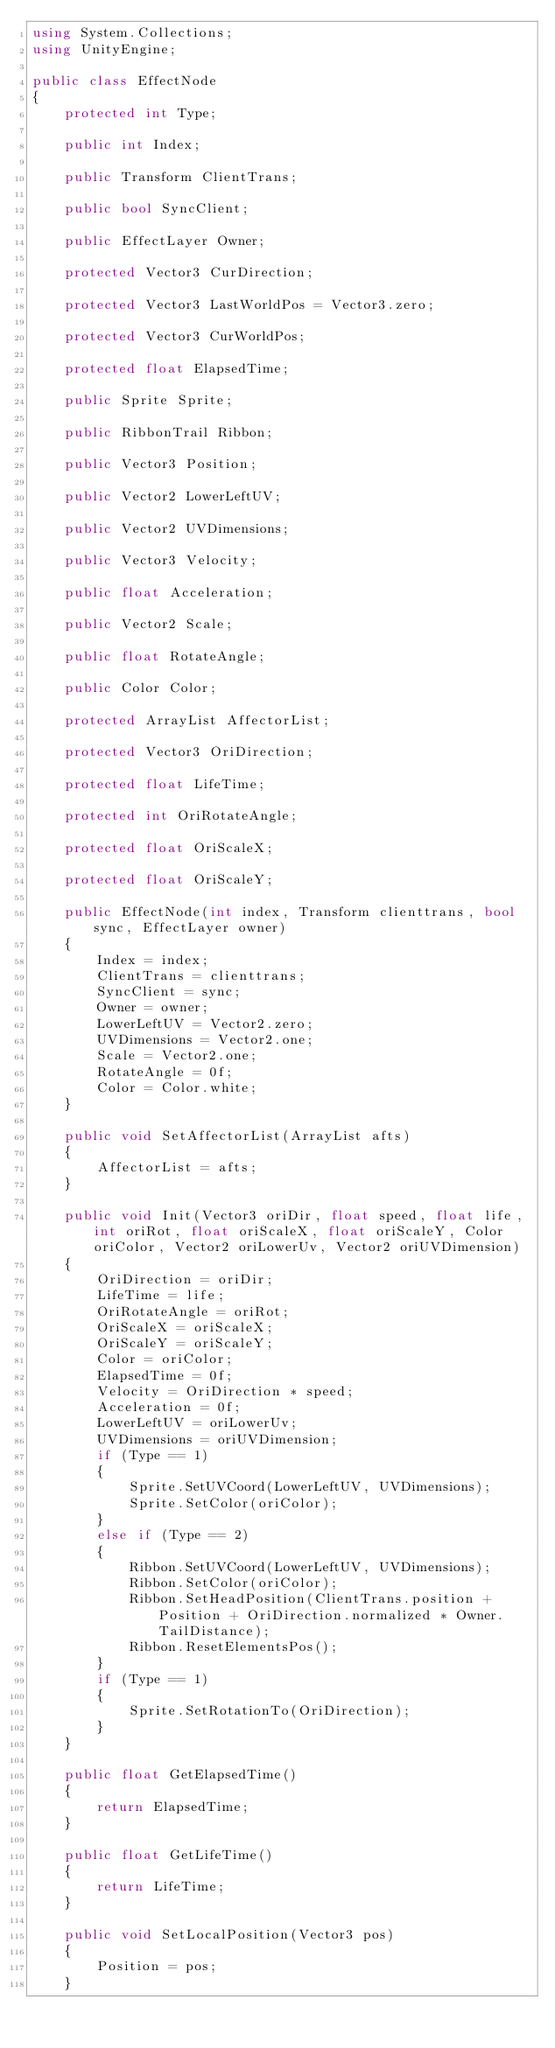<code> <loc_0><loc_0><loc_500><loc_500><_C#_>using System.Collections;
using UnityEngine;

public class EffectNode
{
	protected int Type;

	public int Index;

	public Transform ClientTrans;

	public bool SyncClient;

	public EffectLayer Owner;

	protected Vector3 CurDirection;

	protected Vector3 LastWorldPos = Vector3.zero;

	protected Vector3 CurWorldPos;

	protected float ElapsedTime;

	public Sprite Sprite;

	public RibbonTrail Ribbon;

	public Vector3 Position;

	public Vector2 LowerLeftUV;

	public Vector2 UVDimensions;

	public Vector3 Velocity;

	public float Acceleration;

	public Vector2 Scale;

	public float RotateAngle;

	public Color Color;

	protected ArrayList AffectorList;

	protected Vector3 OriDirection;

	protected float LifeTime;

	protected int OriRotateAngle;

	protected float OriScaleX;

	protected float OriScaleY;

	public EffectNode(int index, Transform clienttrans, bool sync, EffectLayer owner)
	{
		Index = index;
		ClientTrans = clienttrans;
		SyncClient = sync;
		Owner = owner;
		LowerLeftUV = Vector2.zero;
		UVDimensions = Vector2.one;
		Scale = Vector2.one;
		RotateAngle = 0f;
		Color = Color.white;
	}

	public void SetAffectorList(ArrayList afts)
	{
		AffectorList = afts;
	}

	public void Init(Vector3 oriDir, float speed, float life, int oriRot, float oriScaleX, float oriScaleY, Color oriColor, Vector2 oriLowerUv, Vector2 oriUVDimension)
	{
		OriDirection = oriDir;
		LifeTime = life;
		OriRotateAngle = oriRot;
		OriScaleX = oriScaleX;
		OriScaleY = oriScaleY;
		Color = oriColor;
		ElapsedTime = 0f;
		Velocity = OriDirection * speed;
		Acceleration = 0f;
		LowerLeftUV = oriLowerUv;
		UVDimensions = oriUVDimension;
		if (Type == 1)
		{
			Sprite.SetUVCoord(LowerLeftUV, UVDimensions);
			Sprite.SetColor(oriColor);
		}
		else if (Type == 2)
		{
			Ribbon.SetUVCoord(LowerLeftUV, UVDimensions);
			Ribbon.SetColor(oriColor);
			Ribbon.SetHeadPosition(ClientTrans.position + Position + OriDirection.normalized * Owner.TailDistance);
			Ribbon.ResetElementsPos();
		}
		if (Type == 1)
		{
			Sprite.SetRotationTo(OriDirection);
		}
	}

	public float GetElapsedTime()
	{
		return ElapsedTime;
	}

	public float GetLifeTime()
	{
		return LifeTime;
	}

	public void SetLocalPosition(Vector3 pos)
	{
		Position = pos;
	}
</code> 